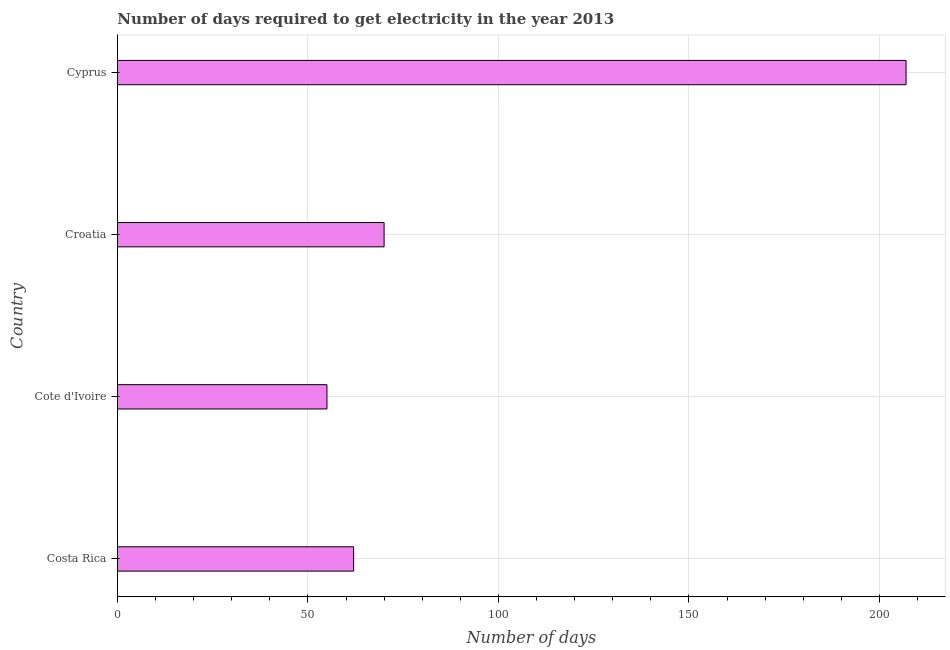Does the graph contain any zero values?
Your response must be concise. No. What is the title of the graph?
Offer a terse response. Number of days required to get electricity in the year 2013. What is the label or title of the X-axis?
Offer a very short reply. Number of days. What is the time to get electricity in Croatia?
Keep it short and to the point. 70. Across all countries, what is the maximum time to get electricity?
Offer a very short reply. 207. In which country was the time to get electricity maximum?
Your answer should be compact. Cyprus. In which country was the time to get electricity minimum?
Your answer should be compact. Cote d'Ivoire. What is the sum of the time to get electricity?
Provide a succinct answer. 394. What is the difference between the time to get electricity in Costa Rica and Cyprus?
Ensure brevity in your answer.  -145. What is the average time to get electricity per country?
Offer a very short reply. 98.5. In how many countries, is the time to get electricity greater than 10 ?
Offer a very short reply. 4. What is the ratio of the time to get electricity in Costa Rica to that in Cote d'Ivoire?
Your answer should be very brief. 1.13. Is the difference between the time to get electricity in Cote d'Ivoire and Croatia greater than the difference between any two countries?
Offer a very short reply. No. What is the difference between the highest and the second highest time to get electricity?
Offer a very short reply. 137. What is the difference between the highest and the lowest time to get electricity?
Offer a terse response. 152. Are all the bars in the graph horizontal?
Ensure brevity in your answer.  Yes. Are the values on the major ticks of X-axis written in scientific E-notation?
Provide a succinct answer. No. What is the Number of days of Cote d'Ivoire?
Provide a short and direct response. 55. What is the Number of days of Cyprus?
Offer a very short reply. 207. What is the difference between the Number of days in Costa Rica and Cyprus?
Make the answer very short. -145. What is the difference between the Number of days in Cote d'Ivoire and Cyprus?
Your answer should be very brief. -152. What is the difference between the Number of days in Croatia and Cyprus?
Give a very brief answer. -137. What is the ratio of the Number of days in Costa Rica to that in Cote d'Ivoire?
Provide a short and direct response. 1.13. What is the ratio of the Number of days in Costa Rica to that in Croatia?
Ensure brevity in your answer.  0.89. What is the ratio of the Number of days in Cote d'Ivoire to that in Croatia?
Provide a short and direct response. 0.79. What is the ratio of the Number of days in Cote d'Ivoire to that in Cyprus?
Your response must be concise. 0.27. What is the ratio of the Number of days in Croatia to that in Cyprus?
Provide a short and direct response. 0.34. 